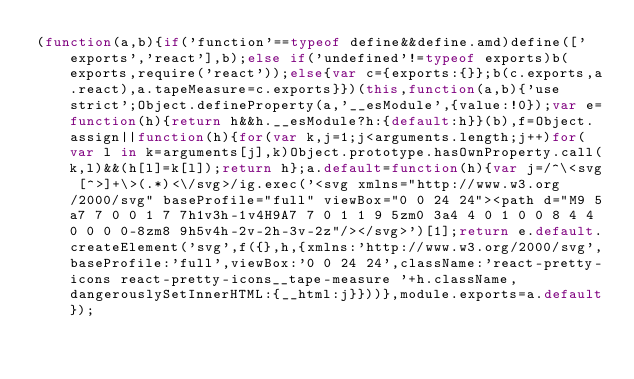Convert code to text. <code><loc_0><loc_0><loc_500><loc_500><_JavaScript_>(function(a,b){if('function'==typeof define&&define.amd)define(['exports','react'],b);else if('undefined'!=typeof exports)b(exports,require('react'));else{var c={exports:{}};b(c.exports,a.react),a.tapeMeasure=c.exports}})(this,function(a,b){'use strict';Object.defineProperty(a,'__esModule',{value:!0});var e=function(h){return h&&h.__esModule?h:{default:h}}(b),f=Object.assign||function(h){for(var k,j=1;j<arguments.length;j++)for(var l in k=arguments[j],k)Object.prototype.hasOwnProperty.call(k,l)&&(h[l]=k[l]);return h};a.default=function(h){var j=/^\<svg [^>]+\>(.*)<\/svg>/ig.exec('<svg xmlns="http://www.w3.org/2000/svg" baseProfile="full" viewBox="0 0 24 24"><path d="M9 5a7 7 0 0 1 7 7h1v3h-1v4H9A7 7 0 1 1 9 5zm0 3a4 4 0 1 0 0 8 4 4 0 0 0 0-8zm8 9h5v4h-2v-2h-3v-2z"/></svg>')[1];return e.default.createElement('svg',f({},h,{xmlns:'http://www.w3.org/2000/svg',baseProfile:'full',viewBox:'0 0 24 24',className:'react-pretty-icons react-pretty-icons__tape-measure '+h.className,dangerouslySetInnerHTML:{__html:j}}))},module.exports=a.default});</code> 